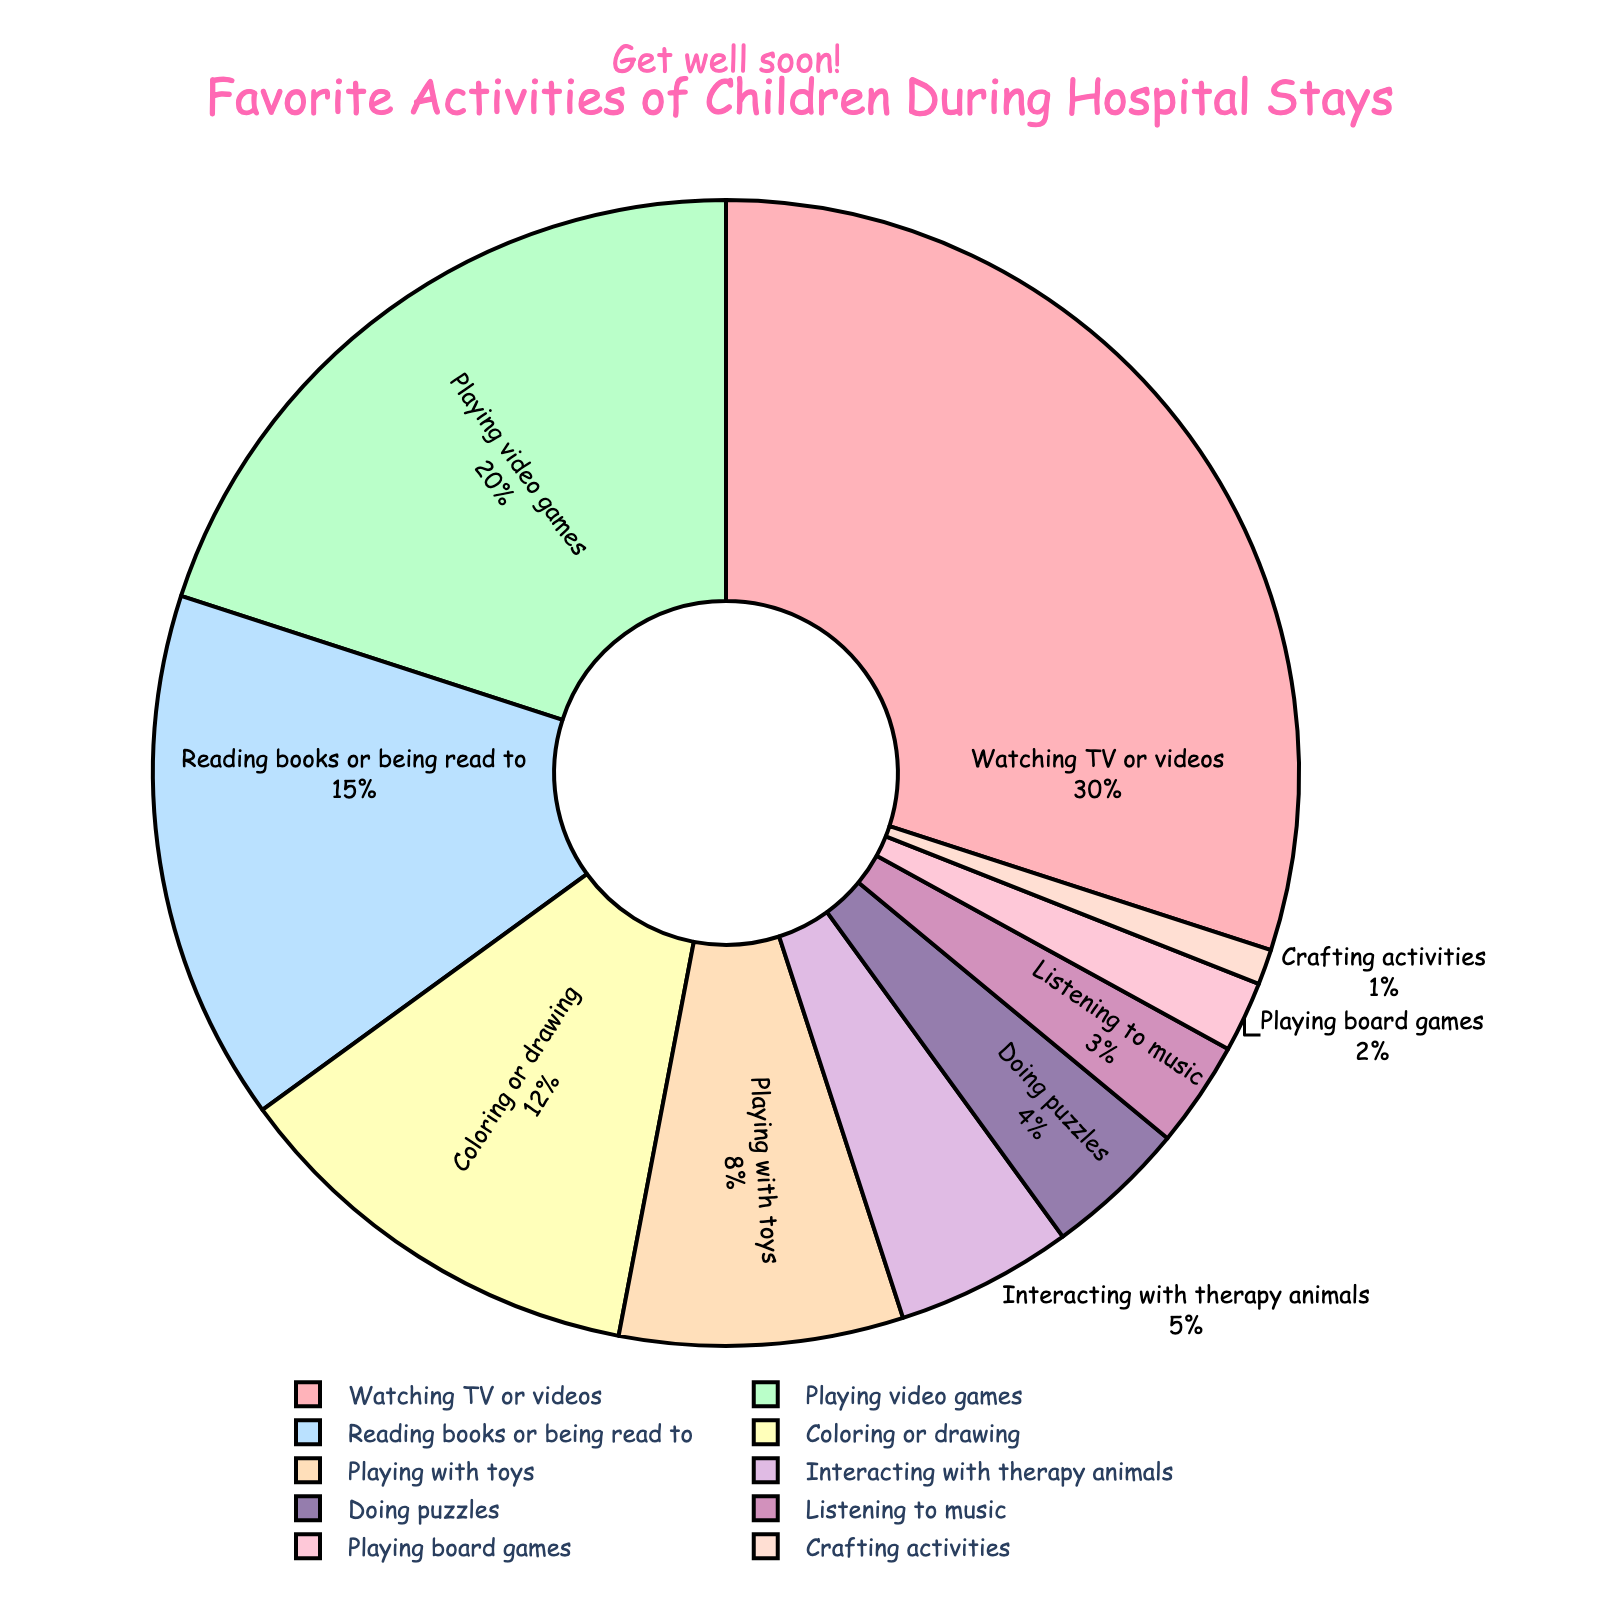what is the most popular activity for children during hospital stays? The pie chart shows different activities and their percentages of popularity. The largest segment corresponds to watching TV or videos, which holds 30% of the total. Therefore, watching TV or videos is the most popular activity.
Answer: Watching TV or videos How much more popular is playing video games than interacting with therapy animals? Playing video games has a 20% share while interacting with therapy animals has a 5% share. To find how much more popular video games are, subtract 5% from 20%: 20% - 5% = 15%.
Answer: 15% Which activity has the least popularity among children? The smallest segment in the pie chart represents the least popular activity, which is crafting activities at 1%.
Answer: Crafting activities What is the combined percentage of children who prefer reading books or being read to and those who enjoy coloring or drawing? According to the chart, reading books or being read to accounts for 15%, and coloring or drawing accounts for 12%. Adding these two percentages together: 15% + 12% = 27%.
Answer: 27% Compare the popularity of playing with toys to doing puzzles. Which one is more popular, and by how much? Playing with toys has an 8% share, while doing puzzles has a 4% share. Playing with toys is more popular. To find by how much, subtract 4% from 8%: 8% - 4% = 4%.
Answer: Playing with toys is more popular by 4% What proportion of children prefer activities involving creativity (Coloring or drawing, Crafting activities)? The activities related to creativity on the chart are coloring or drawing (12%) and crafting activities (1%). Adding these percentages: 12% + 1% = 13%.
Answer: 13% What are the two least popular activities, and what is their combined percentage? The two smallest segments in the pie chart are crafting activities (1%) and playing board games (2%). Their combined percentage is: 1% + 2% = 3%.
Answer: Crafting activities and playing board games, 3% What percentage of children prefer interactive activities (Interacting with therapy animals, Playing board games)? Interactive activities, according to the chart, include interacting with therapy animals (5%) and playing board games (2%). Adding these percentages: 5% + 2% = 7%.
Answer: 7% 